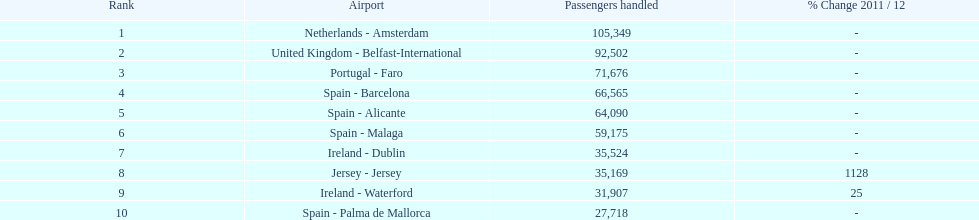Where is the most popular destination for passengers leaving london southend airport? Netherlands - Amsterdam. 